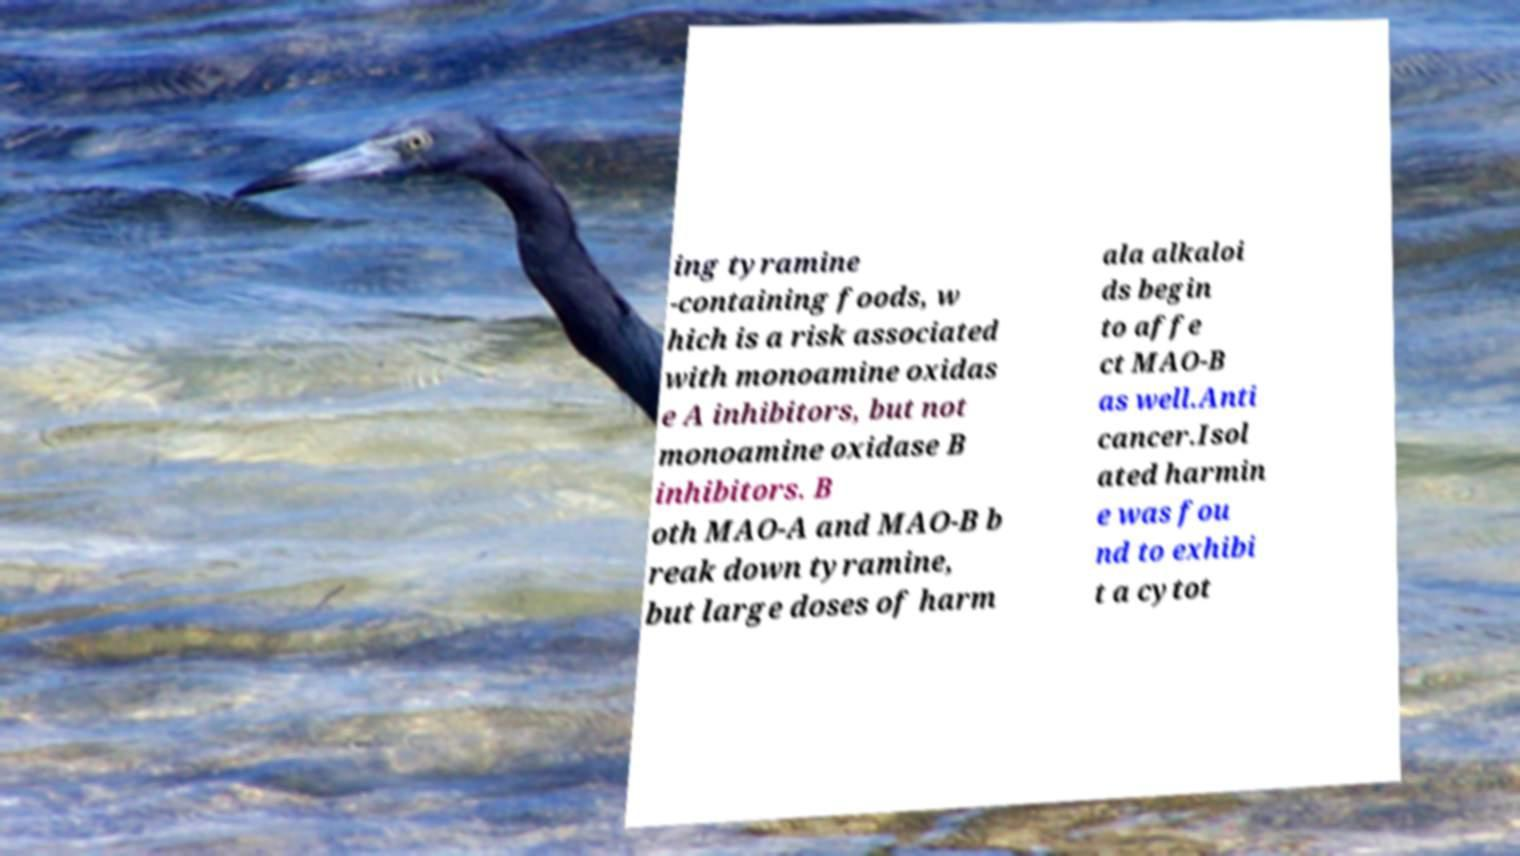There's text embedded in this image that I need extracted. Can you transcribe it verbatim? ing tyramine -containing foods, w hich is a risk associated with monoamine oxidas e A inhibitors, but not monoamine oxidase B inhibitors. B oth MAO-A and MAO-B b reak down tyramine, but large doses of harm ala alkaloi ds begin to affe ct MAO-B as well.Anti cancer.Isol ated harmin e was fou nd to exhibi t a cytot 